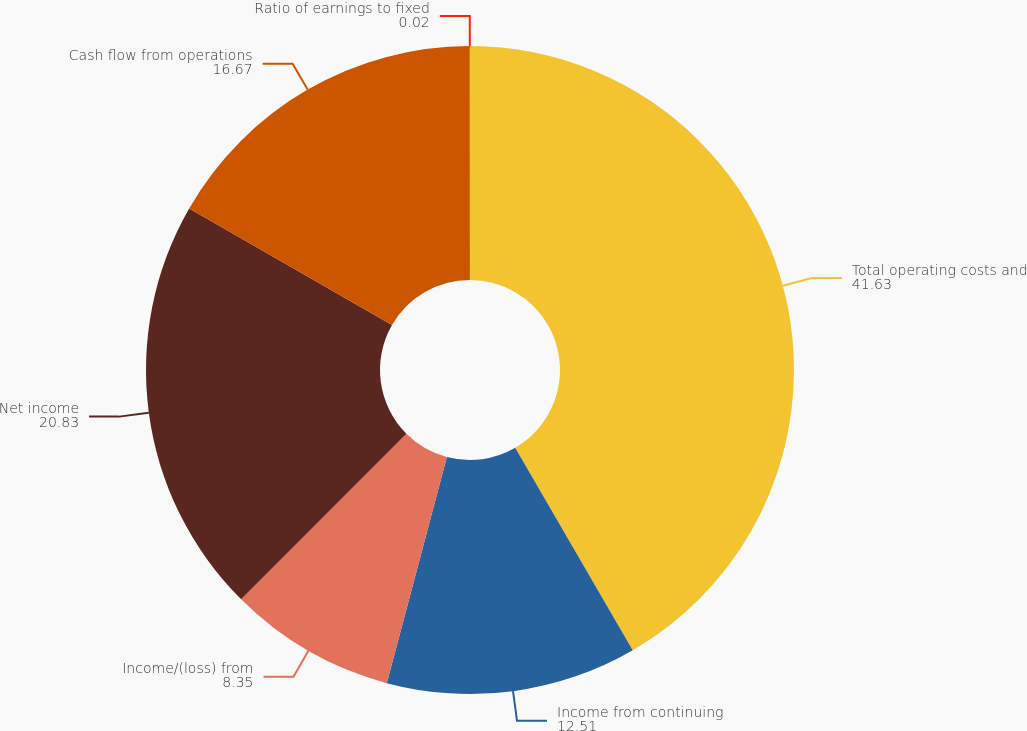Convert chart. <chart><loc_0><loc_0><loc_500><loc_500><pie_chart><fcel>Total operating costs and<fcel>Income from continuing<fcel>Income/(loss) from<fcel>Net income<fcel>Cash flow from operations<fcel>Ratio of earnings to fixed<nl><fcel>41.63%<fcel>12.51%<fcel>8.35%<fcel>20.83%<fcel>16.67%<fcel>0.02%<nl></chart> 